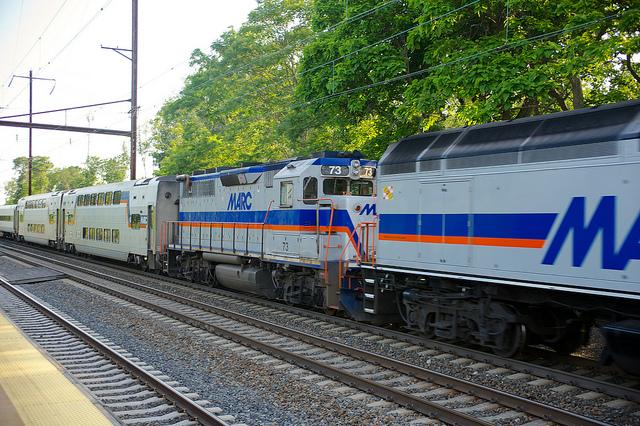What word is written on the train?
Concise answer only. Marc. Is this a speed train?
Concise answer only. No. What is the train doing in the photograph?
Short answer required. Sitting. What type of location is in this photo?
Keep it brief. Train station. What feature was this train designed for?
Give a very brief answer. Passengers. How many tracks can you see?
Write a very short answer. 3. Is the train about to enter a tunnel?
Concise answer only. No. What's the number of the second train?
Keep it brief. 73. 